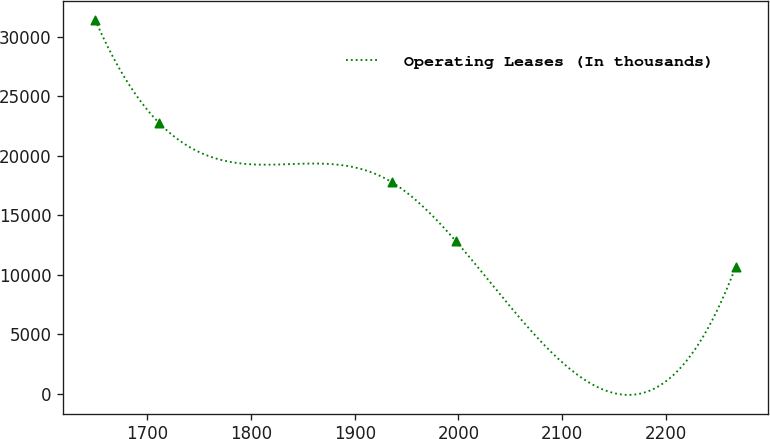<chart> <loc_0><loc_0><loc_500><loc_500><line_chart><ecel><fcel>Operating Leases (In thousands)<nl><fcel>1649.73<fcel>31440.4<nl><fcel>1711.5<fcel>22752.6<nl><fcel>1935.85<fcel>17780.8<nl><fcel>1997.62<fcel>12821.4<nl><fcel>2267.45<fcel>10681.4<nl></chart> 